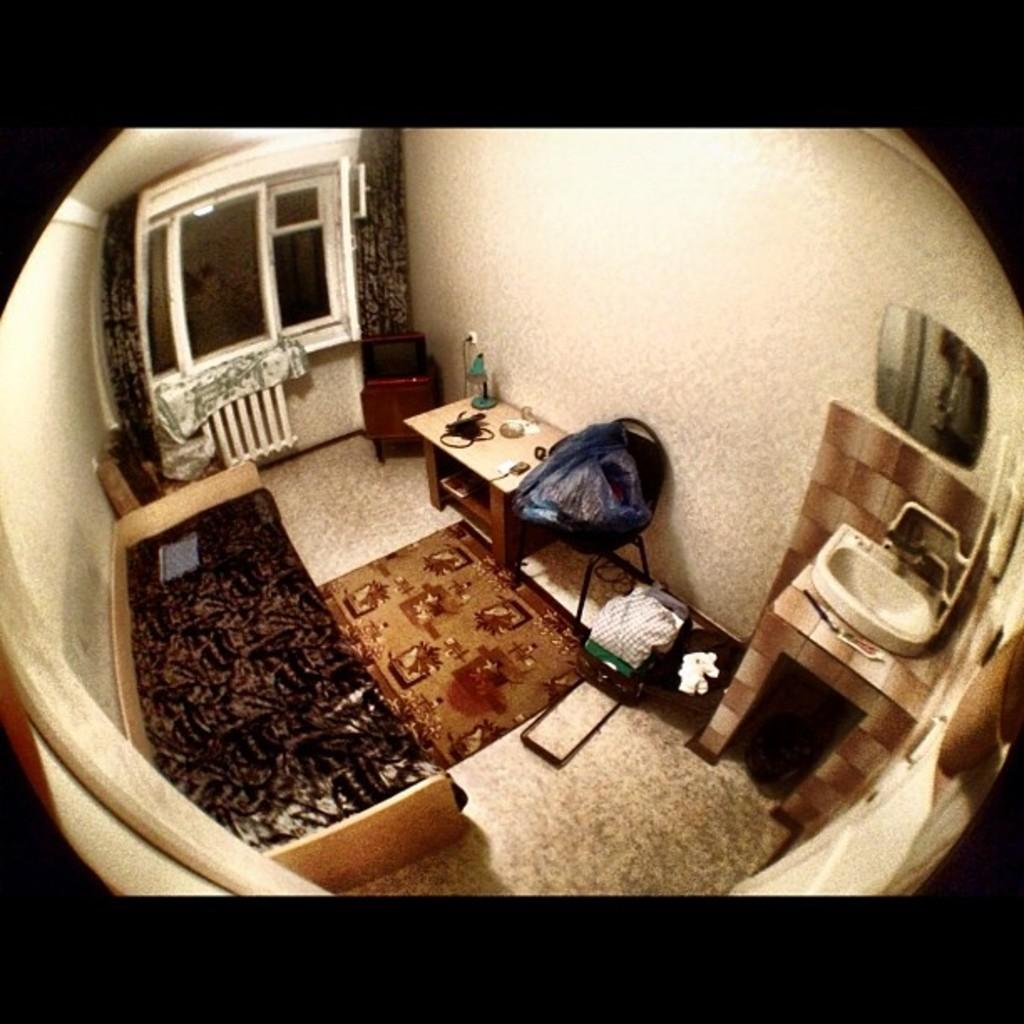What type of furniture is present in the room? There is a bed, a table, and a television in the room. What can be found on the table in the room? There are items on the table in the room. What is used for carrying belongings in the room? There is a bag in the room. What is used for personal hygiene in the room? There is a sink in the room. What is used for personal grooming in the room? There is a mirror in the room. What is placed on the floor near the bed in the room? There is a floor mat in the room. What allows light and air into the room? There are windows in the room. What is used to cover the windows in the room? There are curtains associated with the windows. How many oranges are on the hat in the room? There is no hat or oranges present in the room. 